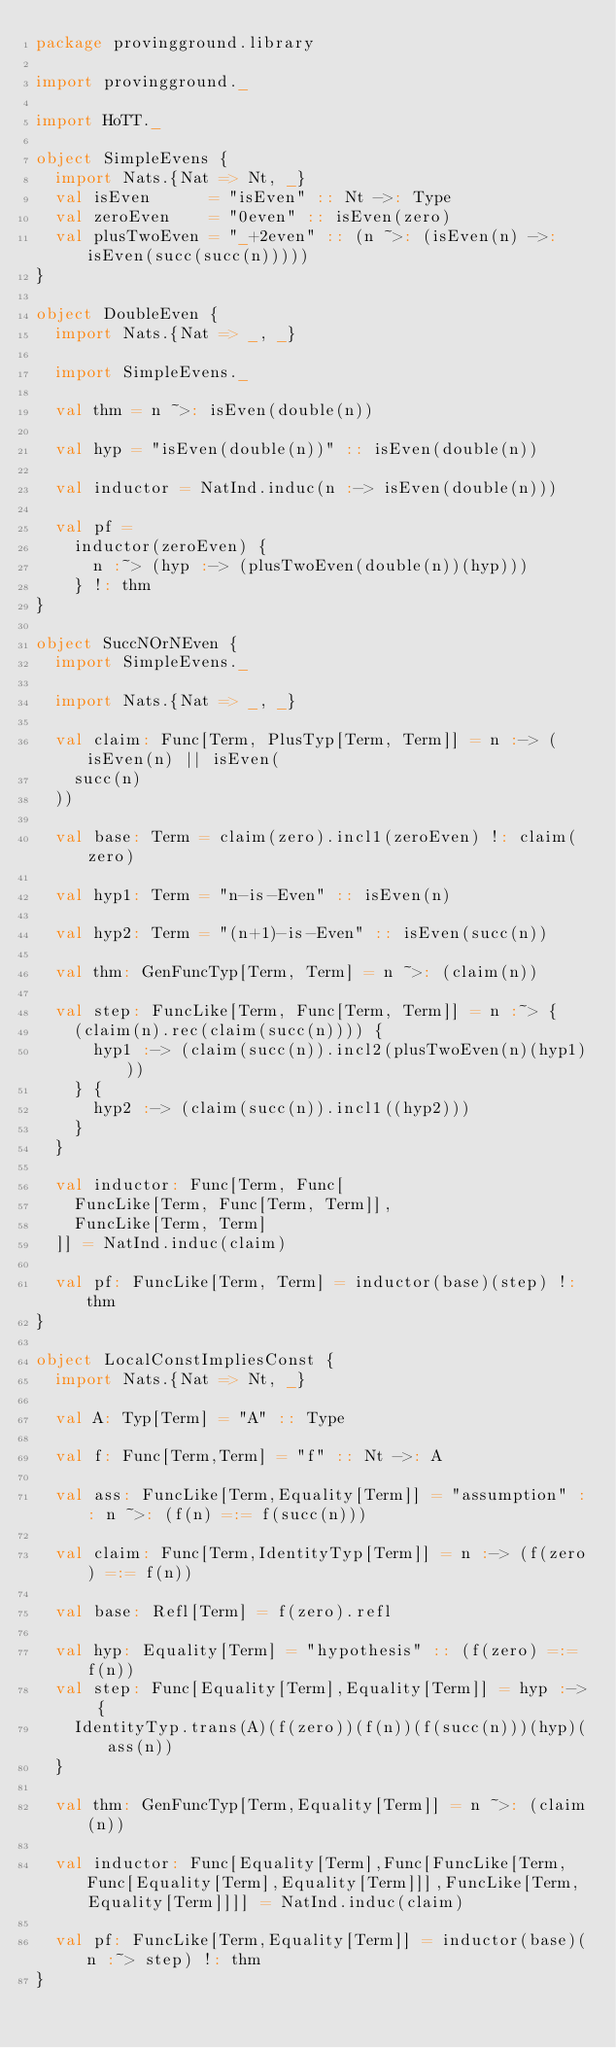Convert code to text. <code><loc_0><loc_0><loc_500><loc_500><_Scala_>package provingground.library

import provingground._

import HoTT._

object SimpleEvens {
  import Nats.{Nat => Nt, _}
  val isEven      = "isEven" :: Nt ->: Type
  val zeroEven    = "0even" :: isEven(zero)
  val plusTwoEven = "_+2even" :: (n ~>: (isEven(n) ->: isEven(succ(succ(n)))))
}

object DoubleEven {
  import Nats.{Nat => _, _}

  import SimpleEvens._

  val thm = n ~>: isEven(double(n))

  val hyp = "isEven(double(n))" :: isEven(double(n))

  val inductor = NatInd.induc(n :-> isEven(double(n)))

  val pf =
    inductor(zeroEven) {
      n :~> (hyp :-> (plusTwoEven(double(n))(hyp)))
    } !: thm
}

object SuccNOrNEven {
  import SimpleEvens._

  import Nats.{Nat => _, _}

  val claim: Func[Term, PlusTyp[Term, Term]] = n :-> (isEven(n) || isEven(
    succ(n)
  ))

  val base: Term = claim(zero).incl1(zeroEven) !: claim(zero)

  val hyp1: Term = "n-is-Even" :: isEven(n)

  val hyp2: Term = "(n+1)-is-Even" :: isEven(succ(n))

  val thm: GenFuncTyp[Term, Term] = n ~>: (claim(n))

  val step: FuncLike[Term, Func[Term, Term]] = n :~> {
    (claim(n).rec(claim(succ(n)))) {
      hyp1 :-> (claim(succ(n)).incl2(plusTwoEven(n)(hyp1)))
    } {
      hyp2 :-> (claim(succ(n)).incl1((hyp2)))
    }
  }

  val inductor: Func[Term, Func[
    FuncLike[Term, Func[Term, Term]],
    FuncLike[Term, Term]
  ]] = NatInd.induc(claim)

  val pf: FuncLike[Term, Term] = inductor(base)(step) !: thm
}

object LocalConstImpliesConst {
  import Nats.{Nat => Nt, _}

  val A: Typ[Term] = "A" :: Type

  val f: Func[Term,Term] = "f" :: Nt ->: A

  val ass: FuncLike[Term,Equality[Term]] = "assumption" :: n ~>: (f(n) =:= f(succ(n)))

  val claim: Func[Term,IdentityTyp[Term]] = n :-> (f(zero) =:= f(n))

  val base: Refl[Term] = f(zero).refl

  val hyp: Equality[Term] = "hypothesis" :: (f(zero) =:= f(n))
  val step: Func[Equality[Term],Equality[Term]] = hyp :-> {
    IdentityTyp.trans(A)(f(zero))(f(n))(f(succ(n)))(hyp)(ass(n))
  }

  val thm: GenFuncTyp[Term,Equality[Term]] = n ~>: (claim(n))

  val inductor: Func[Equality[Term],Func[FuncLike[Term,Func[Equality[Term],Equality[Term]]],FuncLike[Term,Equality[Term]]]] = NatInd.induc(claim)

  val pf: FuncLike[Term,Equality[Term]] = inductor(base)(n :~> step) !: thm
}
</code> 